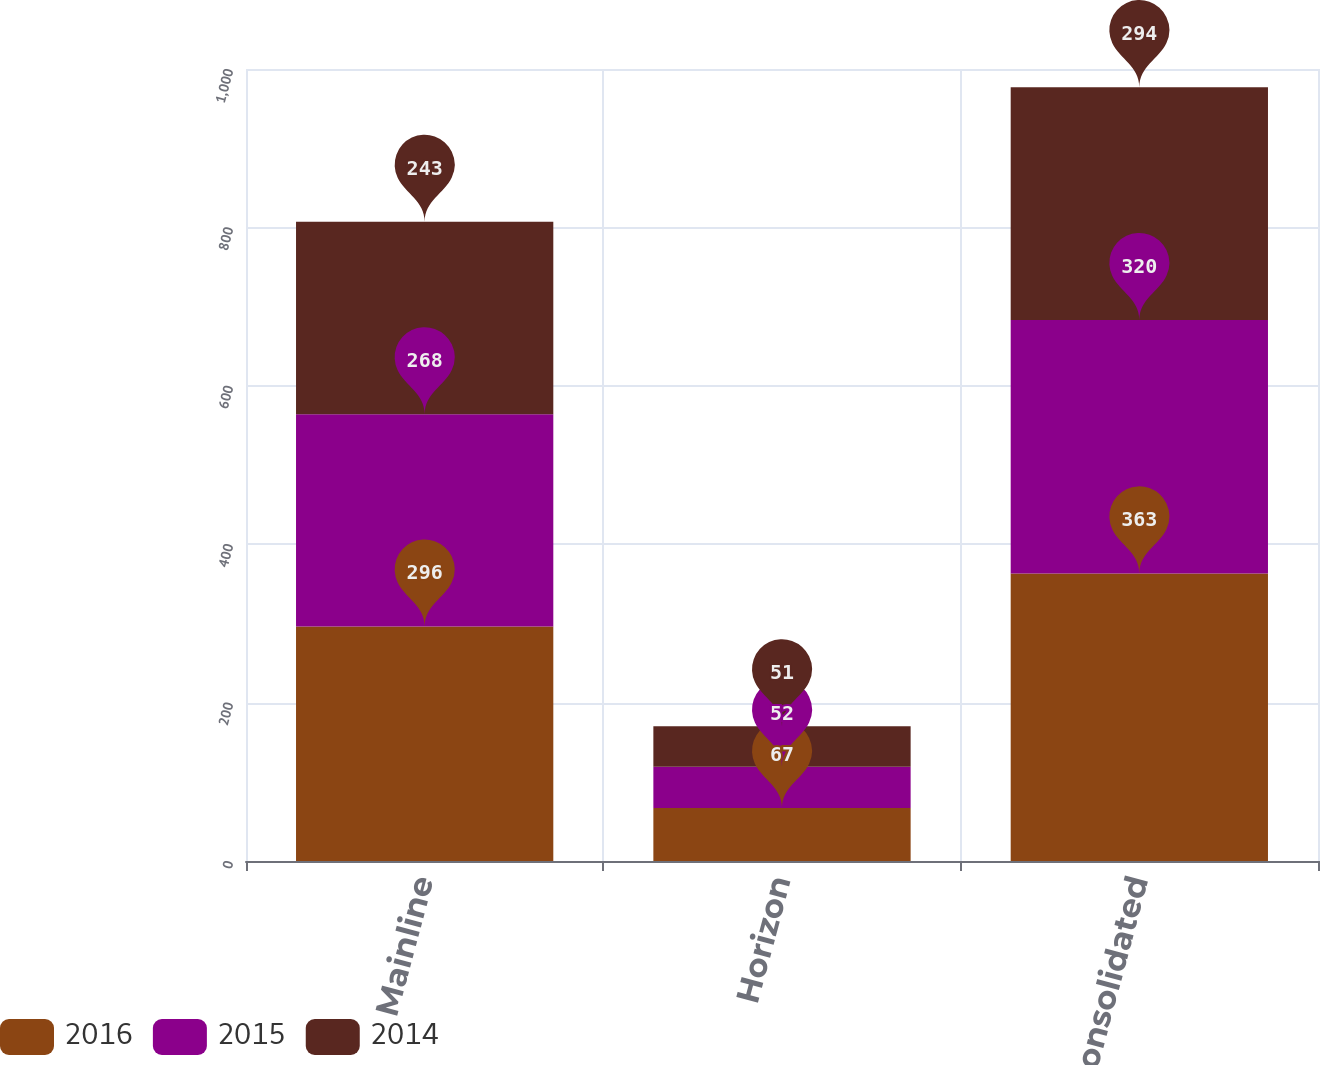Convert chart. <chart><loc_0><loc_0><loc_500><loc_500><stacked_bar_chart><ecel><fcel>Mainline<fcel>Horizon<fcel>Consolidated<nl><fcel>2016<fcel>296<fcel>67<fcel>363<nl><fcel>2015<fcel>268<fcel>52<fcel>320<nl><fcel>2014<fcel>243<fcel>51<fcel>294<nl></chart> 